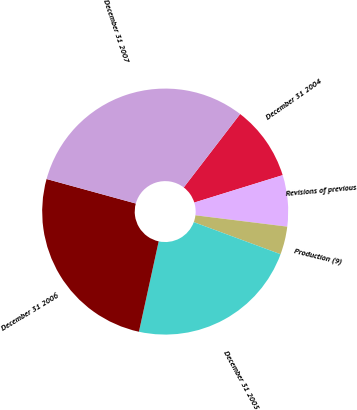Convert chart to OTSL. <chart><loc_0><loc_0><loc_500><loc_500><pie_chart><fcel>December 31 2004<fcel>Revisions of previous<fcel>Production (9)<fcel>December 31 2005<fcel>December 31 2006<fcel>December 31 2007<nl><fcel>9.79%<fcel>6.74%<fcel>3.68%<fcel>22.79%<fcel>25.84%<fcel>31.16%<nl></chart> 